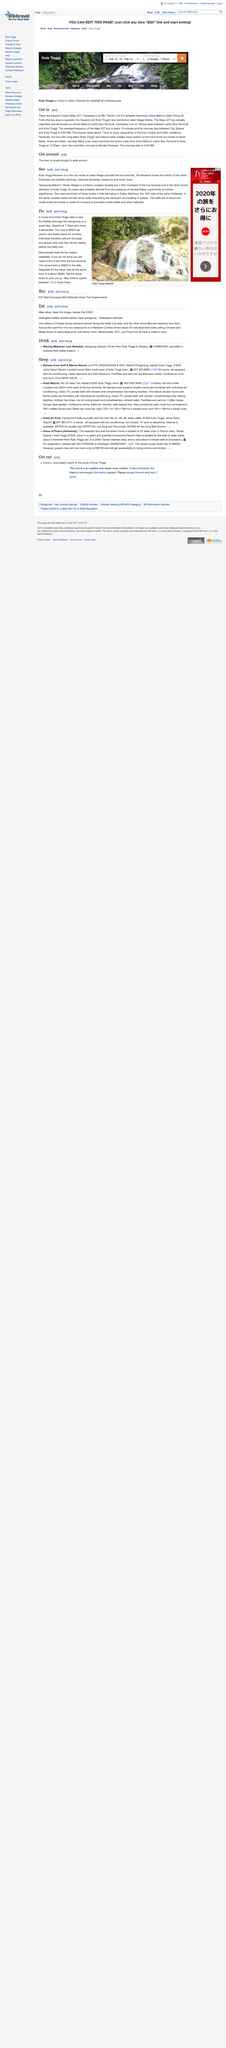Highlight a few significant elements in this photo. The one-way fare on the Maju 227 bus between City Square and Kota Tinggi is 4.80RM. Kampung Makam, also known as "Tomb Village," is a historic complex and popular tourist destination located in Kota Tinggi. The name of this location is believed to be derived from the numerous royal tombs of significant historical value that are present within its boundaries. The Kota Tinggi Museum is located in the city center at Jalan Niaga, approximately 1.5 kilometers northeast of the bus terminal. The phone number for the Hotel Mayres is 607 883 9909. The Sebana Cover Golf & Marina Resort can be reached by dialing 607 826 6688. 